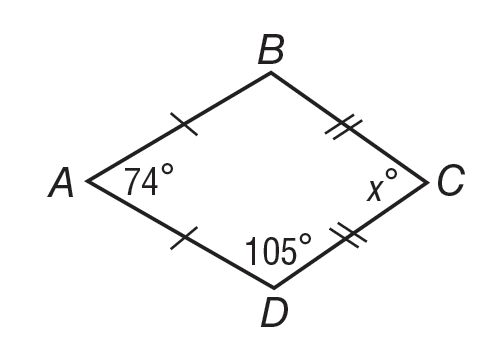Answer the mathemtical geometry problem and directly provide the correct option letter.
Question: If quadrilateral A B C D is a kite, what is m \angle C?
Choices: A: 15 B: 74 C: 76 D: 89 C 